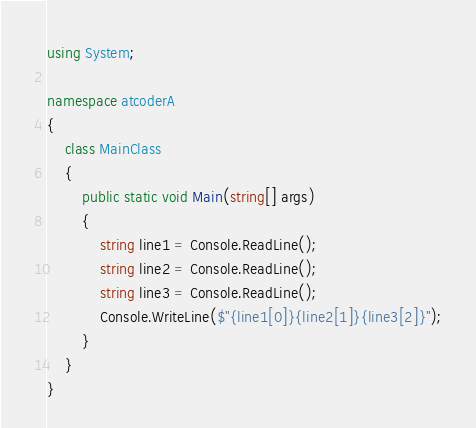Convert code to text. <code><loc_0><loc_0><loc_500><loc_500><_C#_>using System;

namespace atcoderA
{
    class MainClass
    {
        public static void Main(string[] args)
        {
            string line1 = Console.ReadLine();
            string line2 = Console.ReadLine();
            string line3 = Console.ReadLine();
            Console.WriteLine($"{line1[0]}{line2[1]}{line3[2]}");
        }
    }
}</code> 